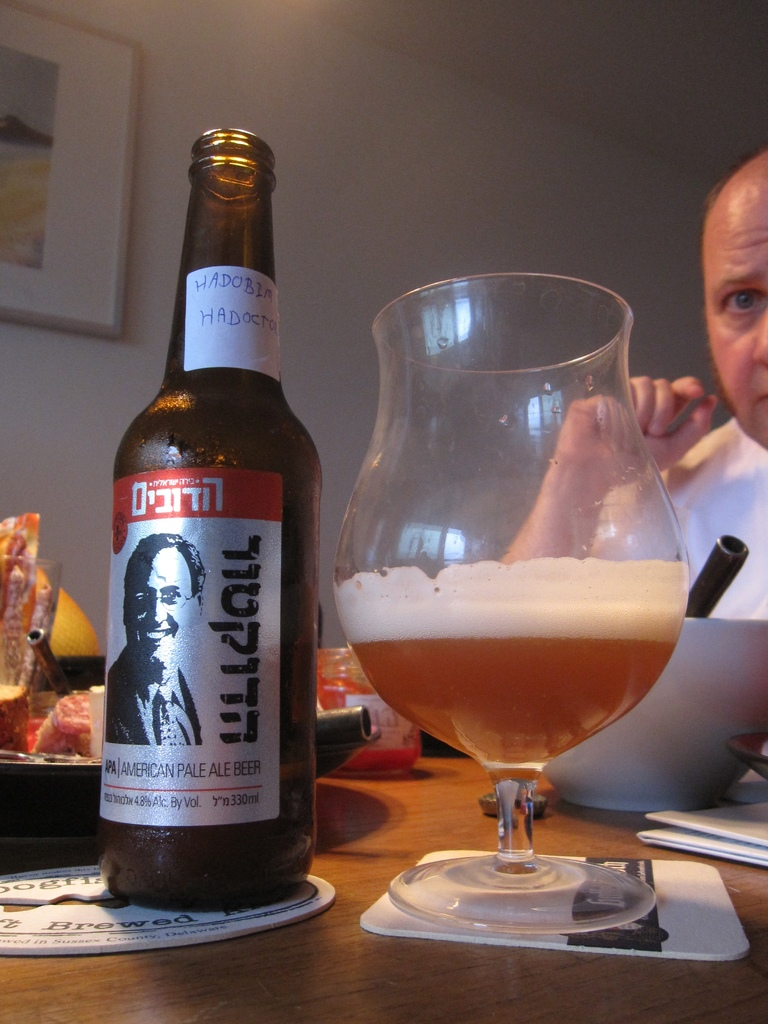What kind of food is the man eating and how does it pair with his beer? The man is eating a rustic, hearty stew which pairs excellently with the hoppy and citrus notes of the American Pale Ale, enhancing the overall dining experience. Describe the setting in which the man is eating. The setting is a warmly lit kitchen with simple and homely decor, featuring a wooden table and casual dinnerware that create an inviting and comfortable dining atmosphere. 